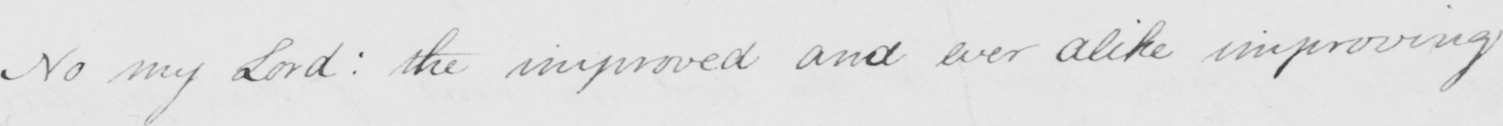What is written in this line of handwriting? No my Lord :  the improved and ever alike improving 